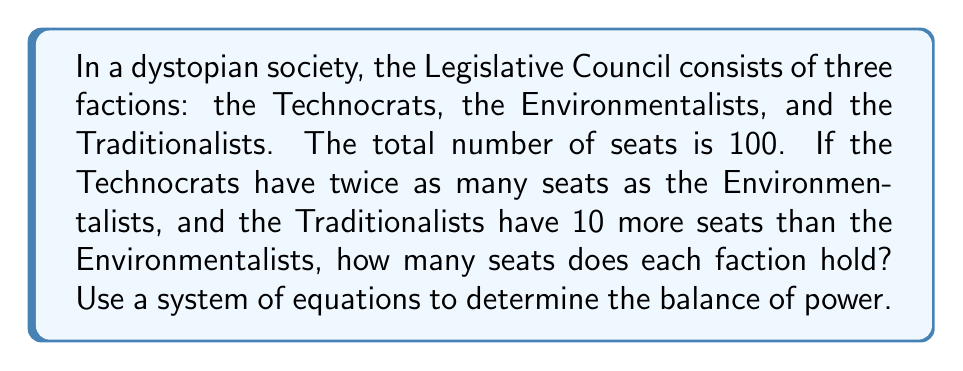Can you solve this math problem? Let's approach this step-by-step:

1) Let's define our variables:
   $x$ = number of seats held by Environmentalists
   $2x$ = number of seats held by Technocrats
   $x + 10$ = number of seats held by Traditionalists

2) We know the total number of seats is 100, so we can set up our equation:
   $$x + 2x + (x + 10) = 100$$

3) Simplify the left side of the equation:
   $$4x + 10 = 100$$

4) Subtract 10 from both sides:
   $$4x = 90$$

5) Divide both sides by 4:
   $$x = 22.5$$

6) Since we can't have fractional seats, we need to round to the nearest whole number:
   Environmentalists: $x = 22$ seats
   Technocrats: $2x = 2(22) = 44$ seats
   Traditionalists: $x + 10 = 22 + 10 = 32$ seats

7) Verify: $22 + 44 + 32 = 98$
   This is the closest whole number solution that maintains the given ratios.

This system of equations reveals the delicate balance of power in the Legislative Council, reflecting the political tensions that could drive the narrative in a speculative fiction story.
Answer: Environmentalists: 22, Technocrats: 44, Traditionalists: 32 